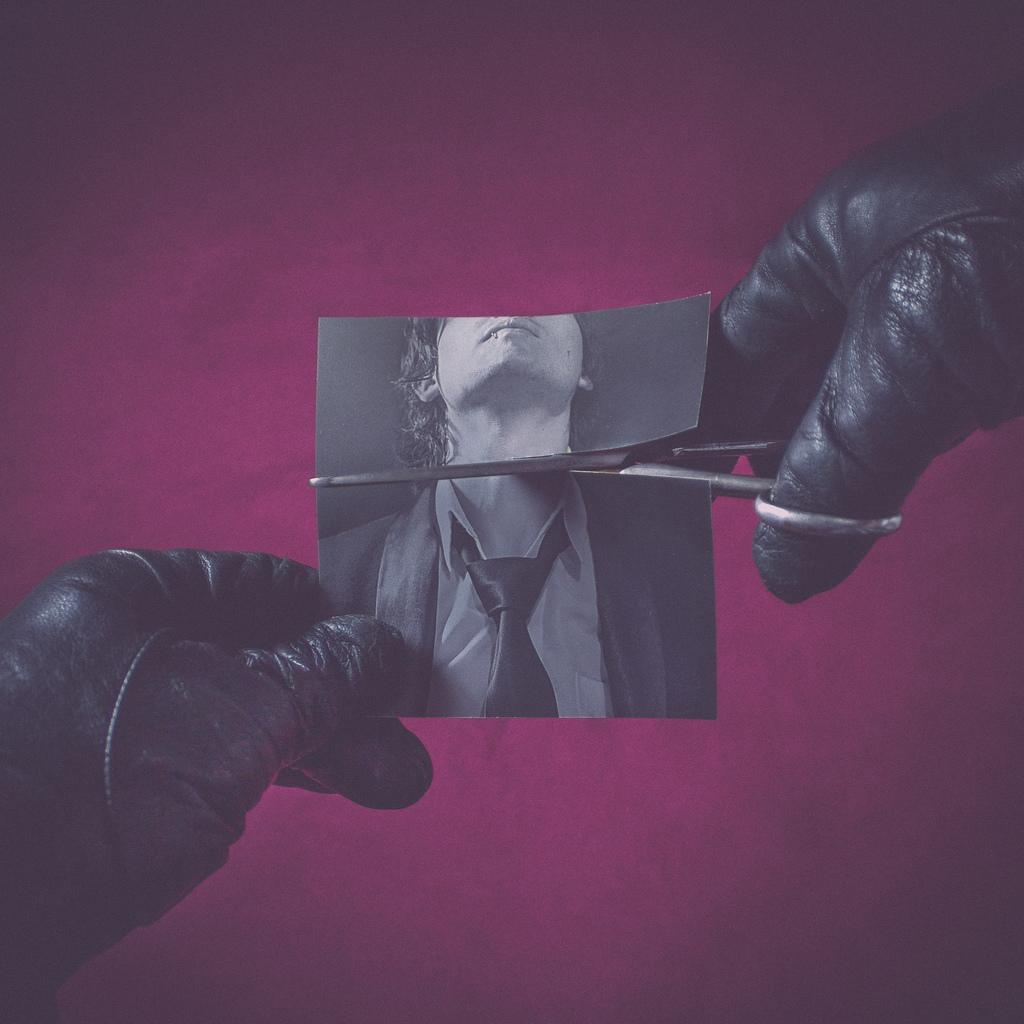What is the main subject of the image? The main subject of the image is human hands. What are the hands holding in the image? The hands are holding a scissor and a photo. Can you describe the photo that is being held? There is a person visible in the photo. Reasoning: Let'g: Let's think step by step in order to produce the conversation. We start by identifying the main subject of the image, which is the human hands. Then, we describe what the hands are holding, which includes a scissor and a photo. Finally, we provide a detail about the photo, mentioning that there is a person visible in it. Absurd Question/Answer: How does the person in the photo express their anger in the image? There is no indication of the person's emotions in the photo, and therefore we cannot determine if they are expressing anger. What type of suit is the person in the photo wearing? There is no person wearing a suit in the photo, as the image only shows human hands holding a scissorissor and a photo with a person visible in it. 